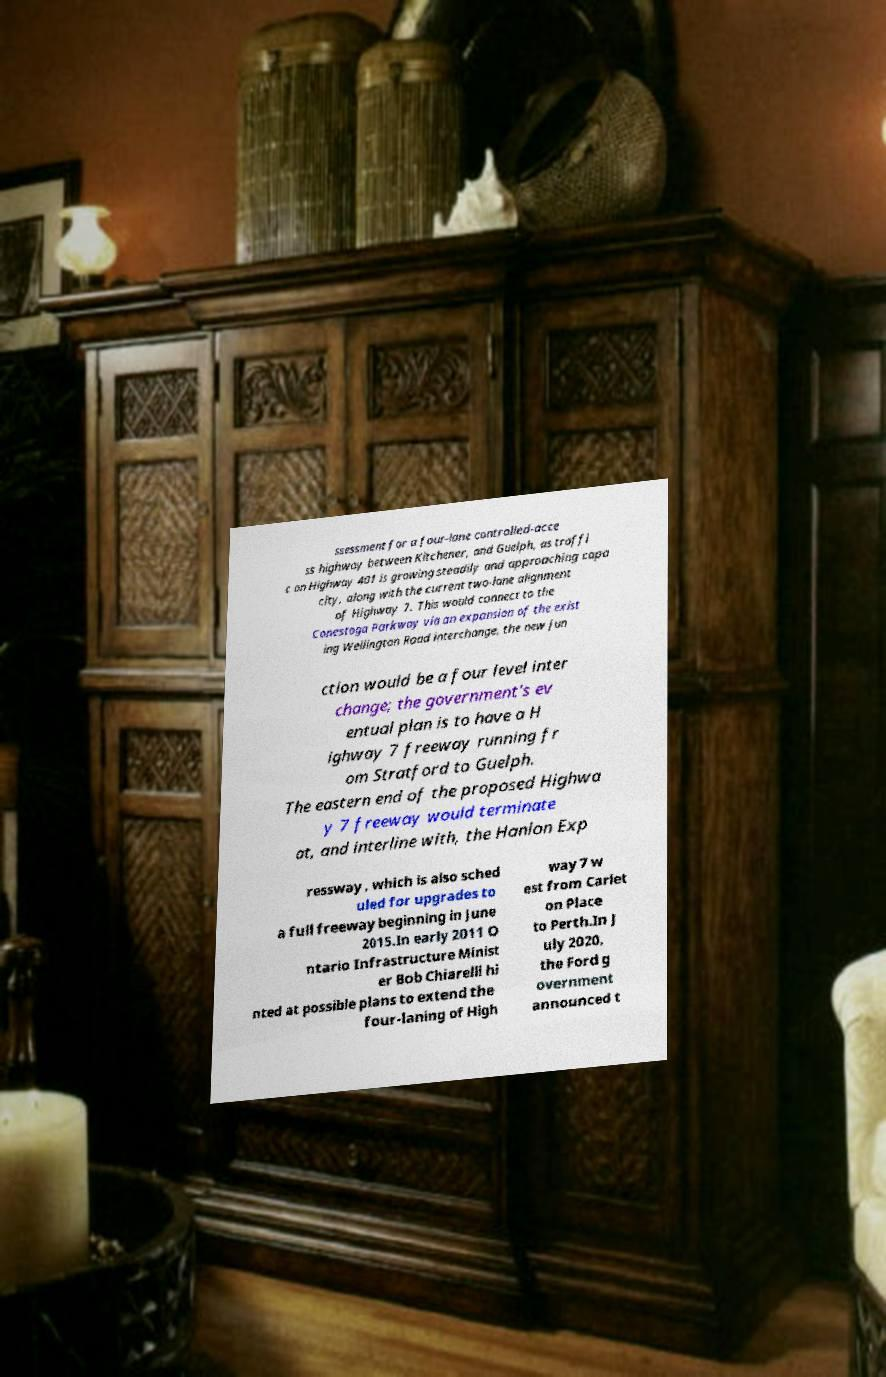Could you assist in decoding the text presented in this image and type it out clearly? ssessment for a four-lane controlled-acce ss highway between Kitchener, and Guelph, as traffi c on Highway 401 is growing steadily and approaching capa city, along with the current two-lane alignment of Highway 7. This would connect to the Conestoga Parkway via an expansion of the exist ing Wellington Road interchange, the new jun ction would be a four level inter change; the government's ev entual plan is to have a H ighway 7 freeway running fr om Stratford to Guelph. The eastern end of the proposed Highwa y 7 freeway would terminate at, and interline with, the Hanlon Exp ressway , which is also sched uled for upgrades to a full freeway beginning in June 2015.In early 2011 O ntario Infrastructure Minist er Bob Chiarelli hi nted at possible plans to extend the four-laning of High way 7 w est from Carlet on Place to Perth.In J uly 2020, the Ford g overnment announced t 